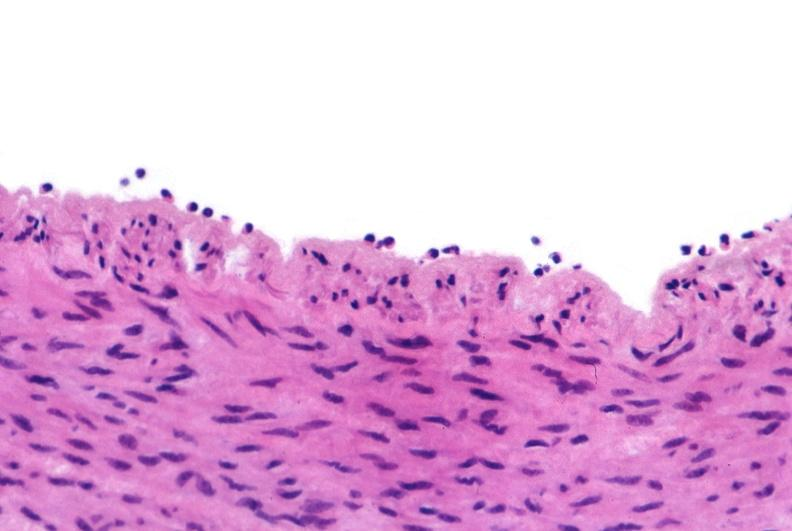what is present?
Answer the question using a single word or phrase. Cardiovascular 